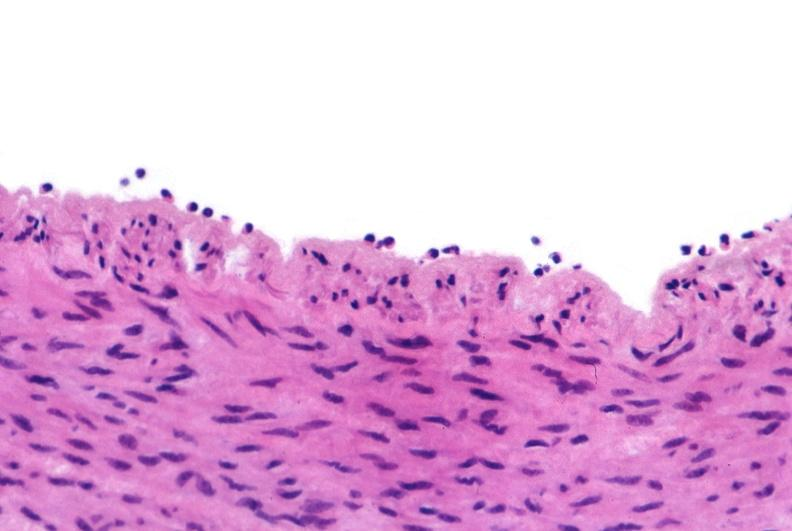what is present?
Answer the question using a single word or phrase. Cardiovascular 